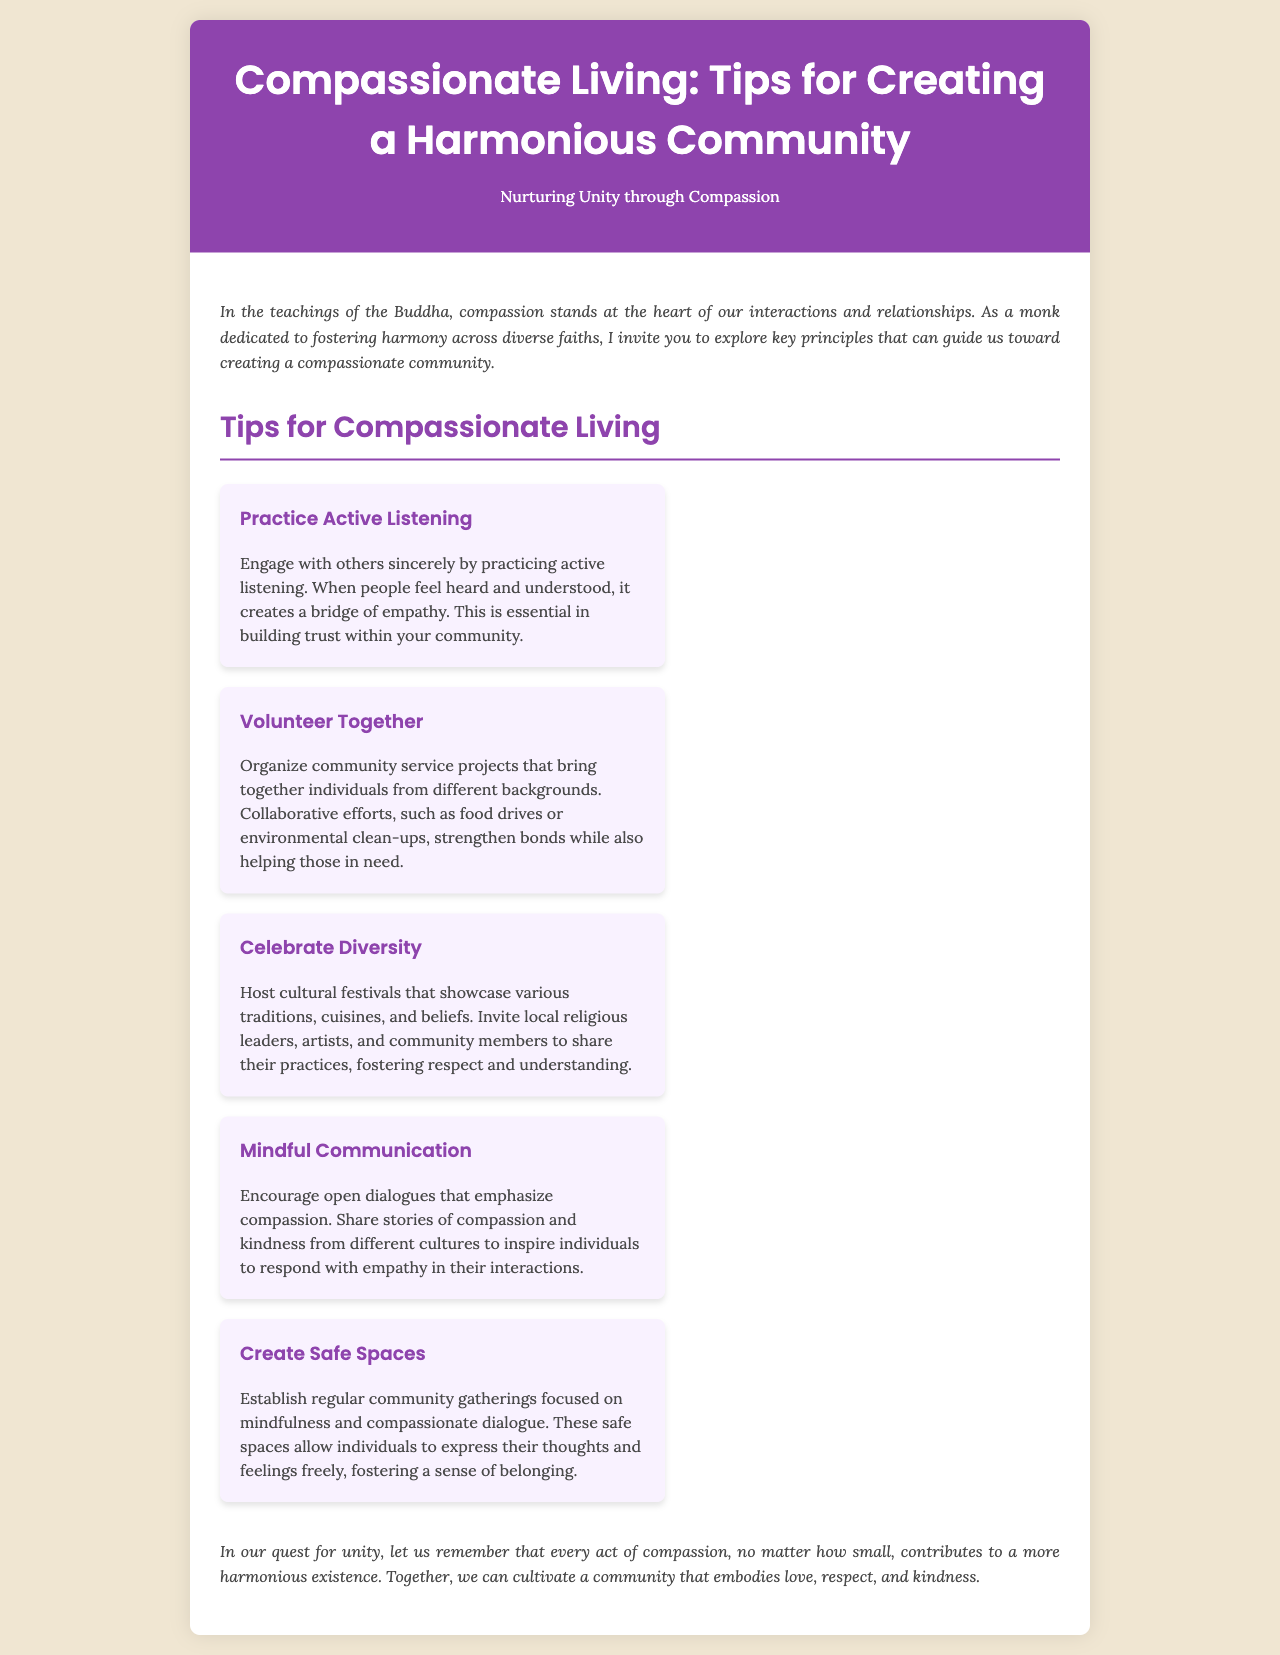What is the title of the brochure? The title of the brochure is prominently displayed at the top of the document, summarizing its purpose.
Answer: Compassionate Living: Tips for Creating a Harmonious Community Who is the target audience of this brochure? The audience can be inferred from the opening paragraph, which speaks to individuals interested in fostering harmony across diverse faiths.
Answer: Individuals interested in fostering harmony What is the theme emphasized in this document? The theme is highlighted in the header and throughout the content, focusing on nurturing connections.
Answer: Nurturing Unity through Compassion How many tips for compassionate living are listed? The number of tips can be determined by counting the sections under the tips heading.
Answer: Five What is the first tip mentioned in the brochure? The first tip is stated clearly as a separate section within the tips.
Answer: Practice Active Listening Which activity is suggested to bring community members together? This is mentioned as a specific example of communal action that enhances relationships among people.
Answer: Organize community service projects What does the brochure suggest to foster respect and understanding? The document outlines an event that promotes cultural awareness and appreciation among diverse groups.
Answer: Host cultural festivals What is the concluding message of the document? The conclusion encapsulates the overarching goal of the tips and the importance of compassion in action.
Answer: Every act of compassion contributes to a more harmonious existence 